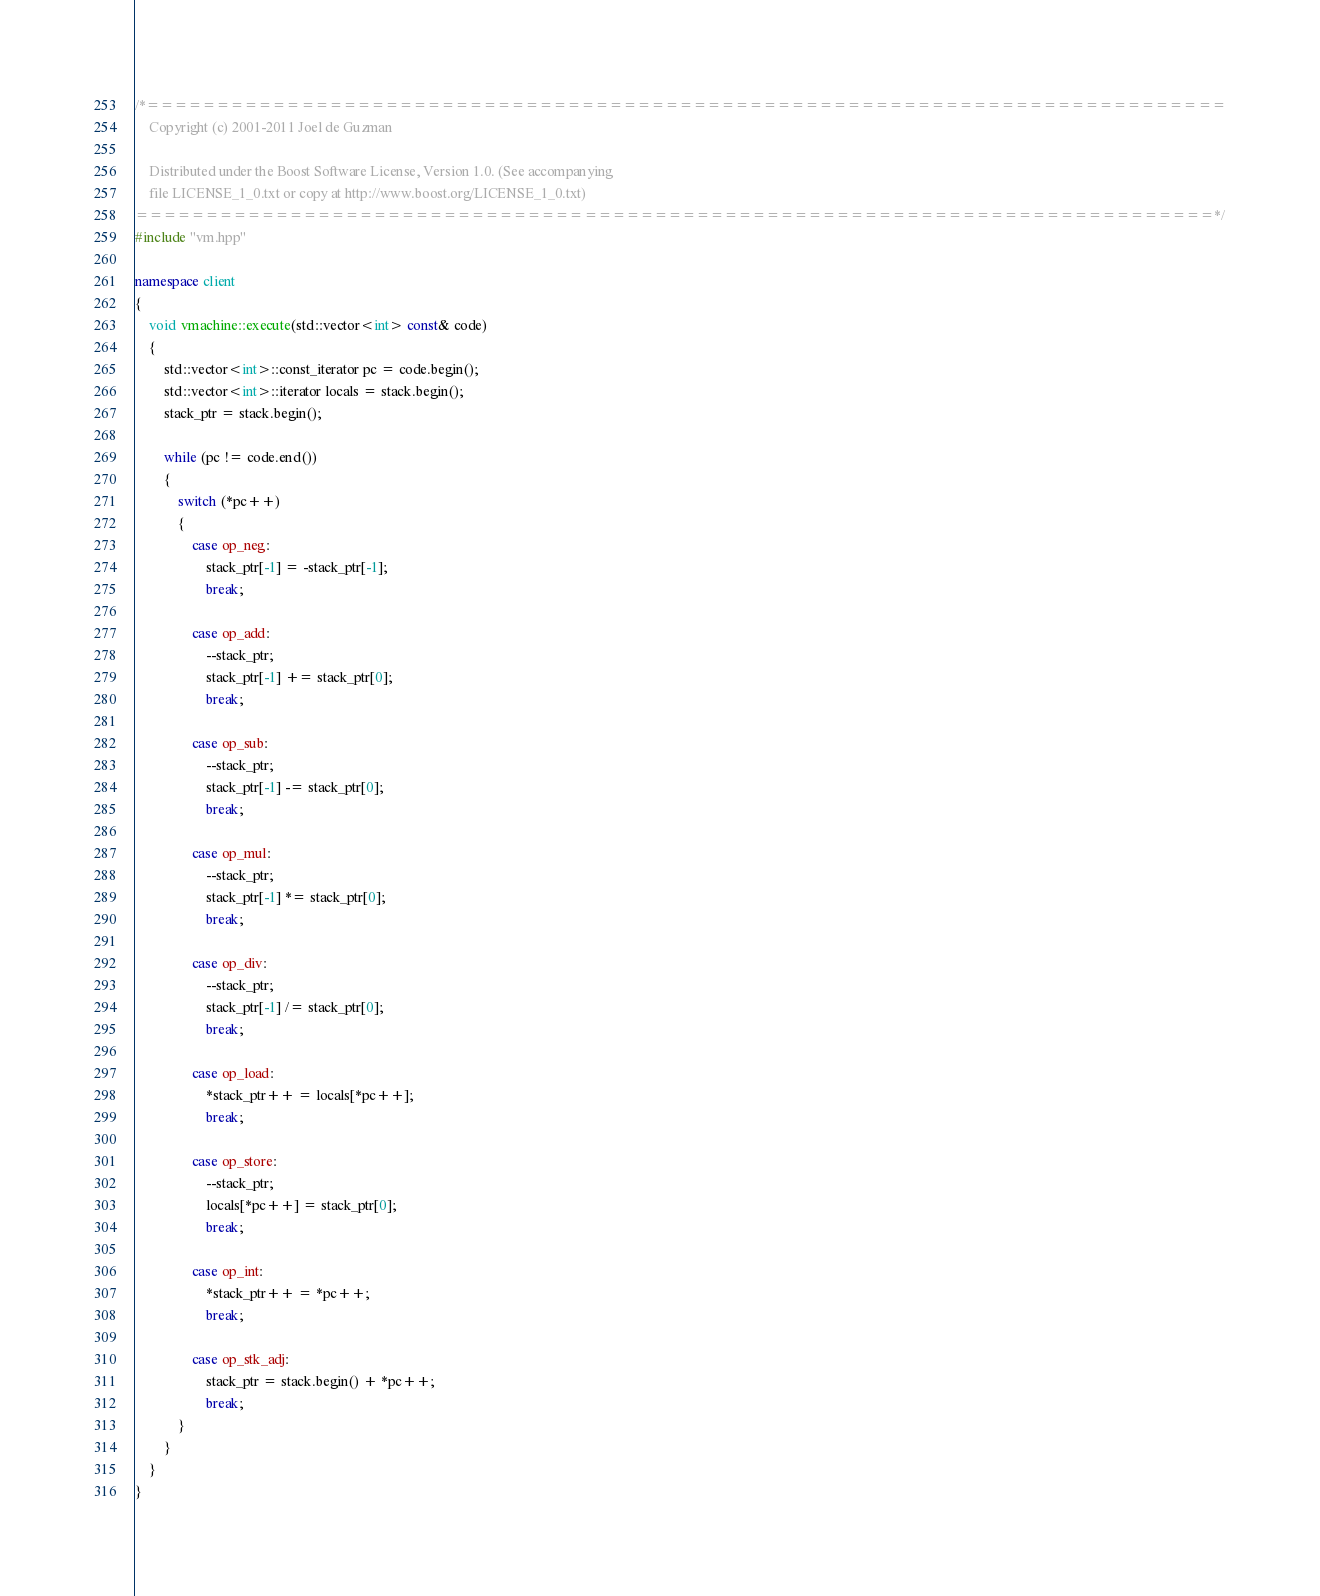<code> <loc_0><loc_0><loc_500><loc_500><_C++_>/*=============================================================================
    Copyright (c) 2001-2011 Joel de Guzman

    Distributed under the Boost Software License, Version 1.0. (See accompanying
    file LICENSE_1_0.txt or copy at http://www.boost.org/LICENSE_1_0.txt)
=============================================================================*/
#include "vm.hpp"

namespace client
{
    void vmachine::execute(std::vector<int> const& code)
    {
        std::vector<int>::const_iterator pc = code.begin();
        std::vector<int>::iterator locals = stack.begin();
        stack_ptr = stack.begin();

        while (pc != code.end())
        {
            switch (*pc++)
            {
                case op_neg:
                    stack_ptr[-1] = -stack_ptr[-1];
                    break;

                case op_add:
                    --stack_ptr;
                    stack_ptr[-1] += stack_ptr[0];
                    break;

                case op_sub:
                    --stack_ptr;
                    stack_ptr[-1] -= stack_ptr[0];
                    break;

                case op_mul:
                    --stack_ptr;
                    stack_ptr[-1] *= stack_ptr[0];
                    break;

                case op_div:
                    --stack_ptr;
                    stack_ptr[-1] /= stack_ptr[0];
                    break;

                case op_load:
                    *stack_ptr++ = locals[*pc++];
                    break;

                case op_store:
                    --stack_ptr;
                    locals[*pc++] = stack_ptr[0];
                    break;

                case op_int:
                    *stack_ptr++ = *pc++;
                    break;

                case op_stk_adj:
                    stack_ptr = stack.begin() + *pc++;
                    break;
            }
        }
    }
}
</code> 